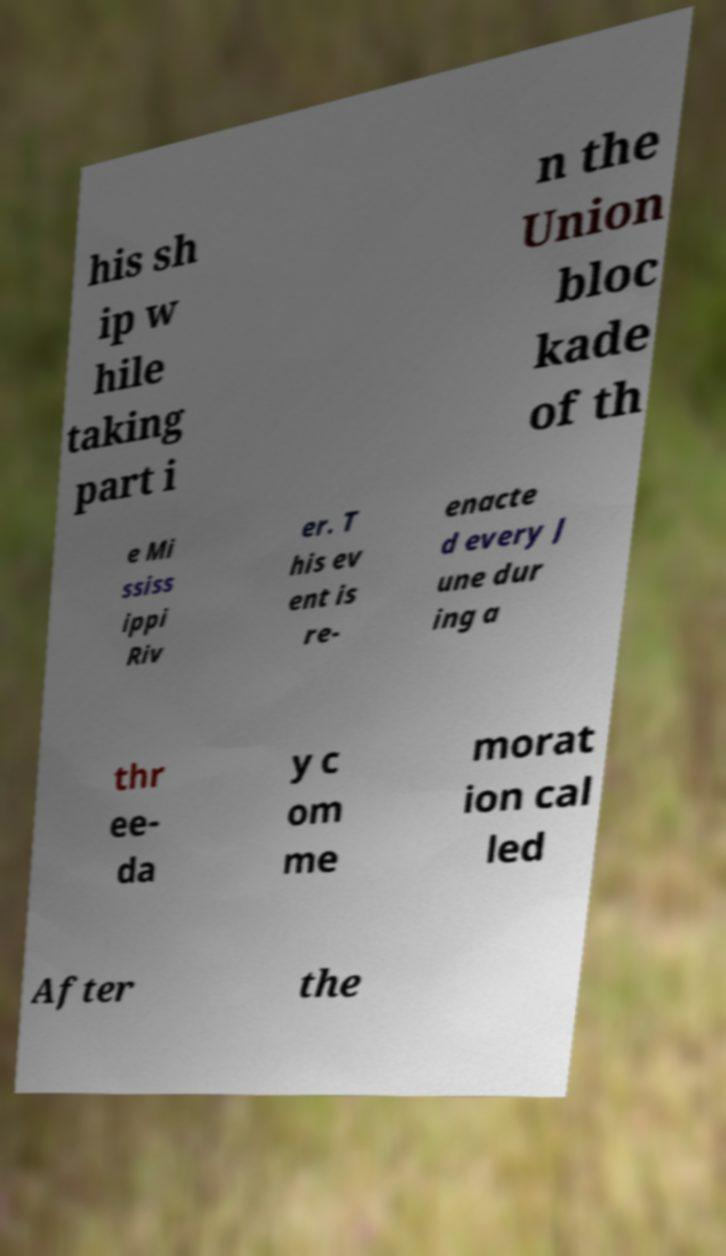For documentation purposes, I need the text within this image transcribed. Could you provide that? his sh ip w hile taking part i n the Union bloc kade of th e Mi ssiss ippi Riv er. T his ev ent is re- enacte d every J une dur ing a thr ee- da y c om me morat ion cal led After the 